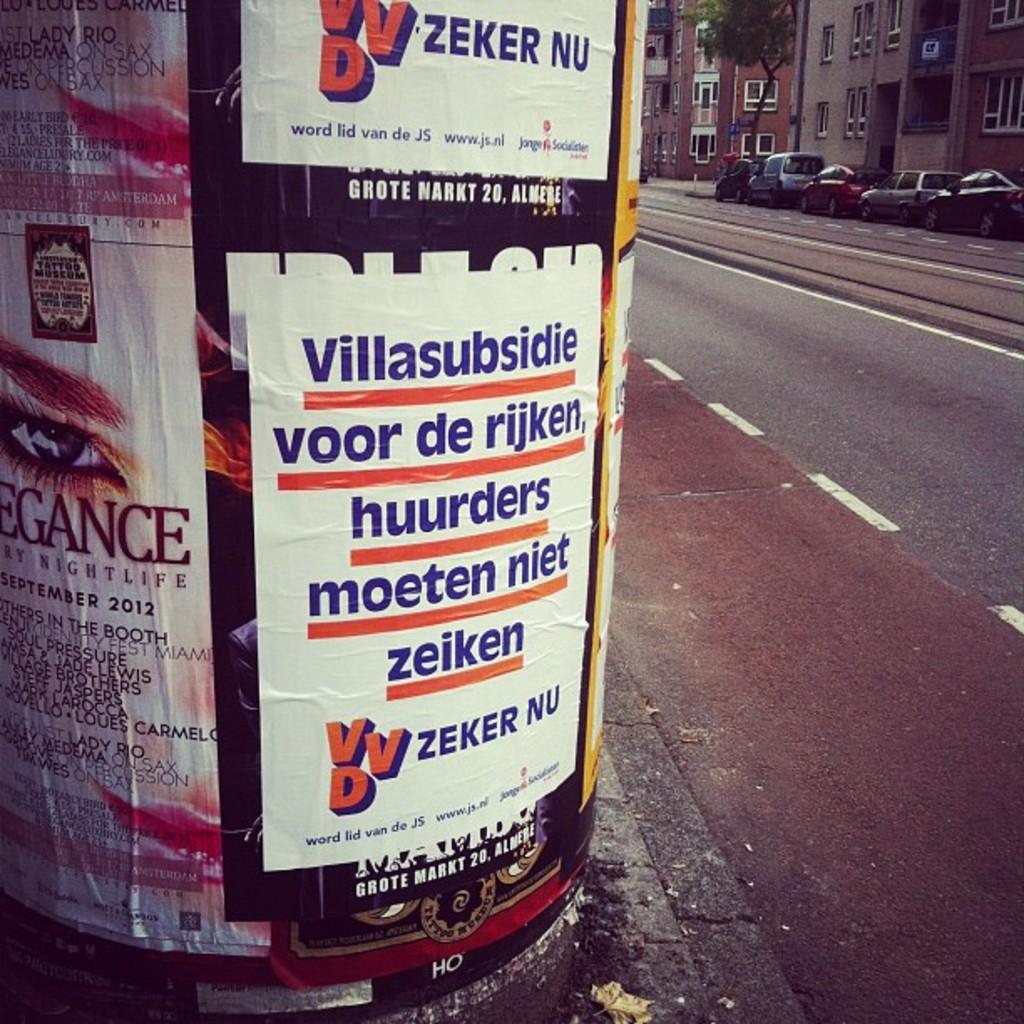What company is advertised on the sign?
Offer a terse response. Zeker nu. What´s the date on the left side of the sing?
Give a very brief answer. September 2012. 